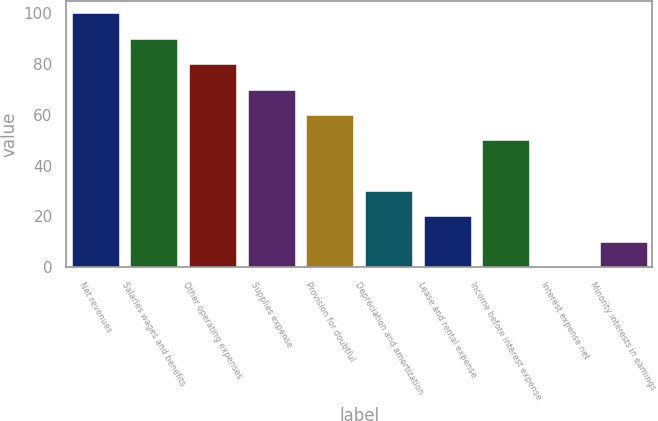Convert chart to OTSL. <chart><loc_0><loc_0><loc_500><loc_500><bar_chart><fcel>Net revenues<fcel>Salaries wages and benefits<fcel>Other operating expenses<fcel>Supplies expense<fcel>Provision for doubtful<fcel>Depreciation and amortization<fcel>Lease and rental expense<fcel>Income before interest expense<fcel>Interest expense net<fcel>Minority interests in earnings<nl><fcel>100<fcel>90.01<fcel>80.02<fcel>70.03<fcel>60.04<fcel>30.07<fcel>20.08<fcel>50.05<fcel>0.1<fcel>10.09<nl></chart> 